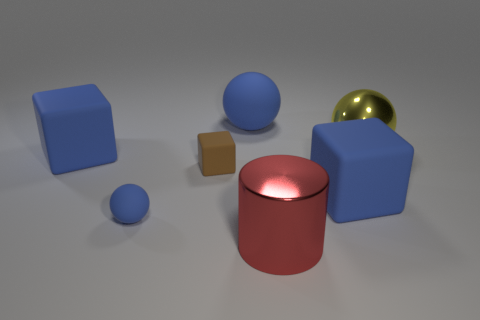The red metal thing that is the same size as the metal sphere is what shape?
Make the answer very short. Cylinder. How many other things are the same color as the small ball?
Provide a short and direct response. 3. What number of things are there?
Provide a succinct answer. 7. How many spheres are right of the large blue ball and behind the yellow metallic sphere?
Your response must be concise. 0. What is the material of the large red cylinder?
Offer a terse response. Metal. Are there any small yellow metal objects?
Give a very brief answer. No. What is the color of the shiny thing that is behind the brown object?
Make the answer very short. Yellow. There is a blue sphere behind the blue rubber object that is to the right of the big metallic cylinder; what number of large rubber balls are to the left of it?
Offer a terse response. 0. There is a big object that is on the left side of the big yellow ball and to the right of the large red cylinder; what is it made of?
Give a very brief answer. Rubber. Is the material of the small blue object the same as the large sphere that is left of the big yellow sphere?
Offer a very short reply. Yes. 